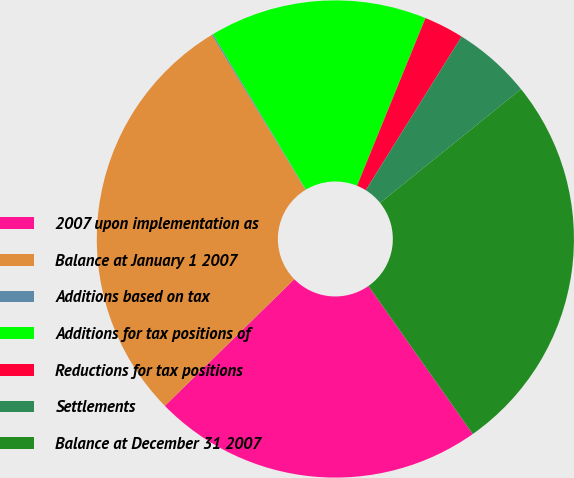Convert chart. <chart><loc_0><loc_0><loc_500><loc_500><pie_chart><fcel>2007 upon implementation as<fcel>Balance at January 1 2007<fcel>Additions based on tax<fcel>Additions for tax positions of<fcel>Reductions for tax positions<fcel>Settlements<fcel>Balance at December 31 2007<nl><fcel>22.44%<fcel>28.66%<fcel>0.09%<fcel>14.74%<fcel>2.71%<fcel>5.32%<fcel>26.04%<nl></chart> 